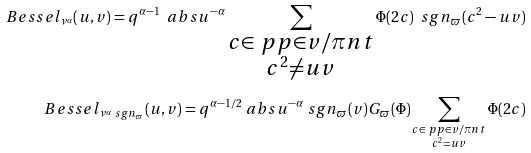<formula> <loc_0><loc_0><loc_500><loc_500>\ B e s s e l _ { \nu ^ { \alpha } } ( u , v ) = q ^ { \alpha - 1 } \ a b s u ^ { - \alpha } \sum _ { \substack { c \in \ p p \in v / \pi n t \\ c ^ { 2 } \ne u v } } \Phi ( 2 c ) \ s g n _ { \varpi } ( c ^ { 2 } - u v ) \\ \ B e s s e l _ { \nu ^ { \alpha } \ s g n _ { \varpi } } ( u , v ) = q ^ { \alpha - 1 / 2 } \ a b s u ^ { - \alpha } \ s g n _ { \varpi } ( v ) G _ { \varpi } ( \Phi ) \sum _ { \substack { c \in \ p p \in v / \pi n t \\ c ^ { 2 } = u v } } \Phi ( 2 c )</formula> 